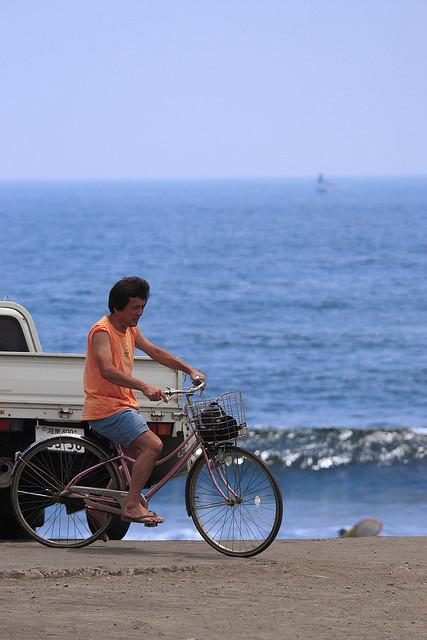What kind of power does the pink bicycle run on? Please explain your reasoning. man power. The power is manpower. 